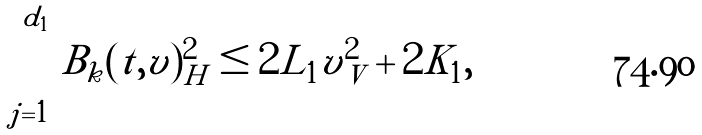<formula> <loc_0><loc_0><loc_500><loc_500>\sum _ { j = 1 } ^ { d _ { 1 } } | B _ { k } ( t , v ) | ^ { 2 } _ { H } \leq 2 L _ { 1 } | v | _ { V } ^ { 2 } + 2 K _ { 1 } ,</formula> 